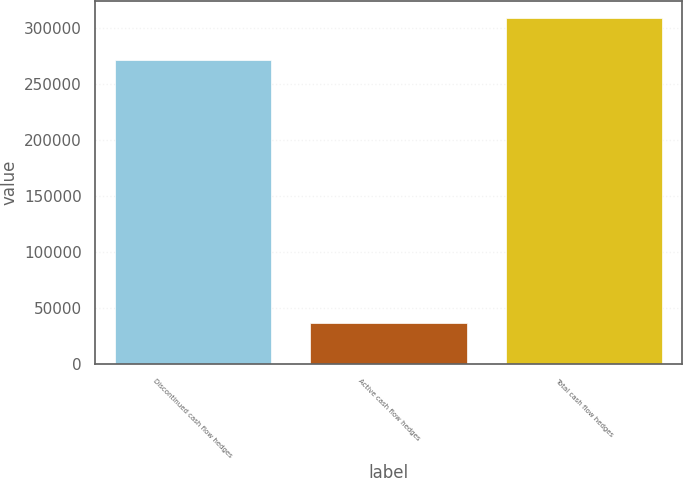Convert chart to OTSL. <chart><loc_0><loc_0><loc_500><loc_500><bar_chart><fcel>Discontinued cash flow hedges<fcel>Active cash flow hedges<fcel>Total cash flow hedges<nl><fcel>271595<fcel>36903<fcel>308498<nl></chart> 